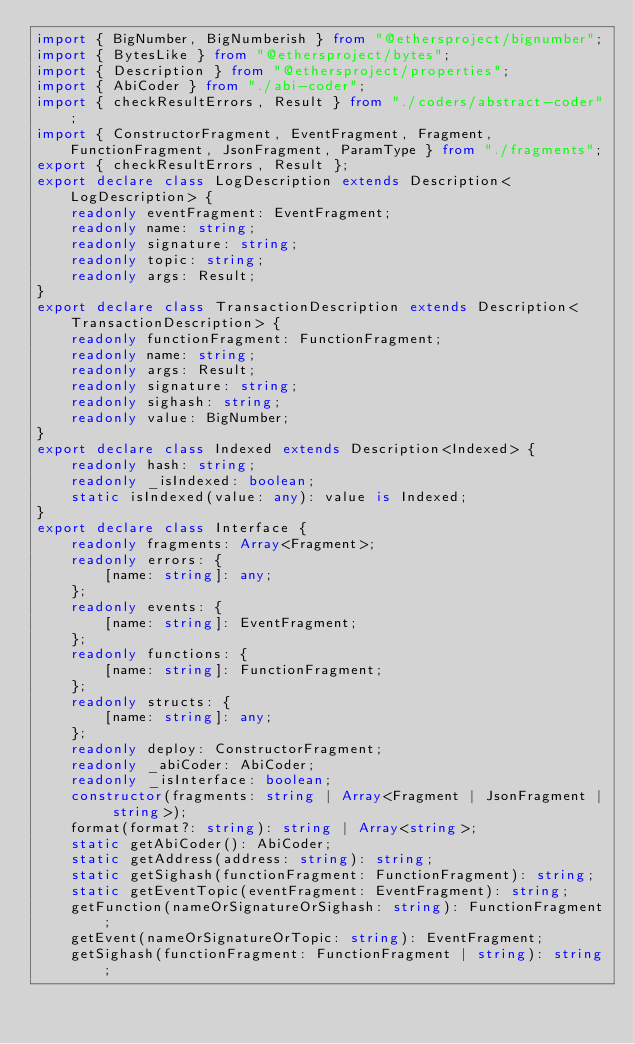Convert code to text. <code><loc_0><loc_0><loc_500><loc_500><_TypeScript_>import { BigNumber, BigNumberish } from "@ethersproject/bignumber";
import { BytesLike } from "@ethersproject/bytes";
import { Description } from "@ethersproject/properties";
import { AbiCoder } from "./abi-coder";
import { checkResultErrors, Result } from "./coders/abstract-coder";
import { ConstructorFragment, EventFragment, Fragment, FunctionFragment, JsonFragment, ParamType } from "./fragments";
export { checkResultErrors, Result };
export declare class LogDescription extends Description<LogDescription> {
    readonly eventFragment: EventFragment;
    readonly name: string;
    readonly signature: string;
    readonly topic: string;
    readonly args: Result;
}
export declare class TransactionDescription extends Description<TransactionDescription> {
    readonly functionFragment: FunctionFragment;
    readonly name: string;
    readonly args: Result;
    readonly signature: string;
    readonly sighash: string;
    readonly value: BigNumber;
}
export declare class Indexed extends Description<Indexed> {
    readonly hash: string;
    readonly _isIndexed: boolean;
    static isIndexed(value: any): value is Indexed;
}
export declare class Interface {
    readonly fragments: Array<Fragment>;
    readonly errors: {
        [name: string]: any;
    };
    readonly events: {
        [name: string]: EventFragment;
    };
    readonly functions: {
        [name: string]: FunctionFragment;
    };
    readonly structs: {
        [name: string]: any;
    };
    readonly deploy: ConstructorFragment;
    readonly _abiCoder: AbiCoder;
    readonly _isInterface: boolean;
    constructor(fragments: string | Array<Fragment | JsonFragment | string>);
    format(format?: string): string | Array<string>;
    static getAbiCoder(): AbiCoder;
    static getAddress(address: string): string;
    static getSighash(functionFragment: FunctionFragment): string;
    static getEventTopic(eventFragment: EventFragment): string;
    getFunction(nameOrSignatureOrSighash: string): FunctionFragment;
    getEvent(nameOrSignatureOrTopic: string): EventFragment;
    getSighash(functionFragment: FunctionFragment | string): string;</code> 